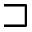<formula> <loc_0><loc_0><loc_500><loc_500>\sqsupset</formula> 